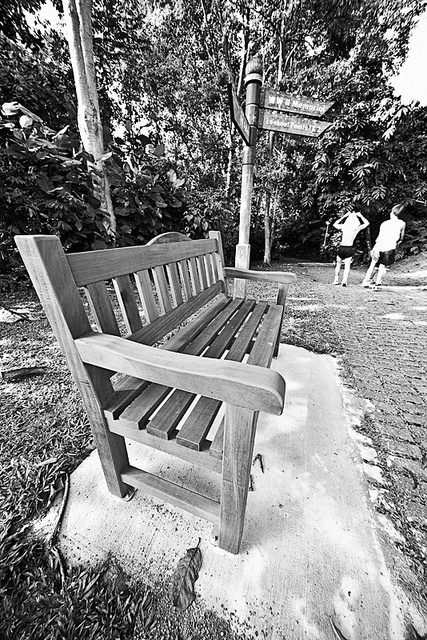Describe the objects in this image and their specific colors. I can see bench in black, darkgray, gray, and lightgray tones, people in black, white, darkgray, and gray tones, and people in black, white, darkgray, and gray tones in this image. 